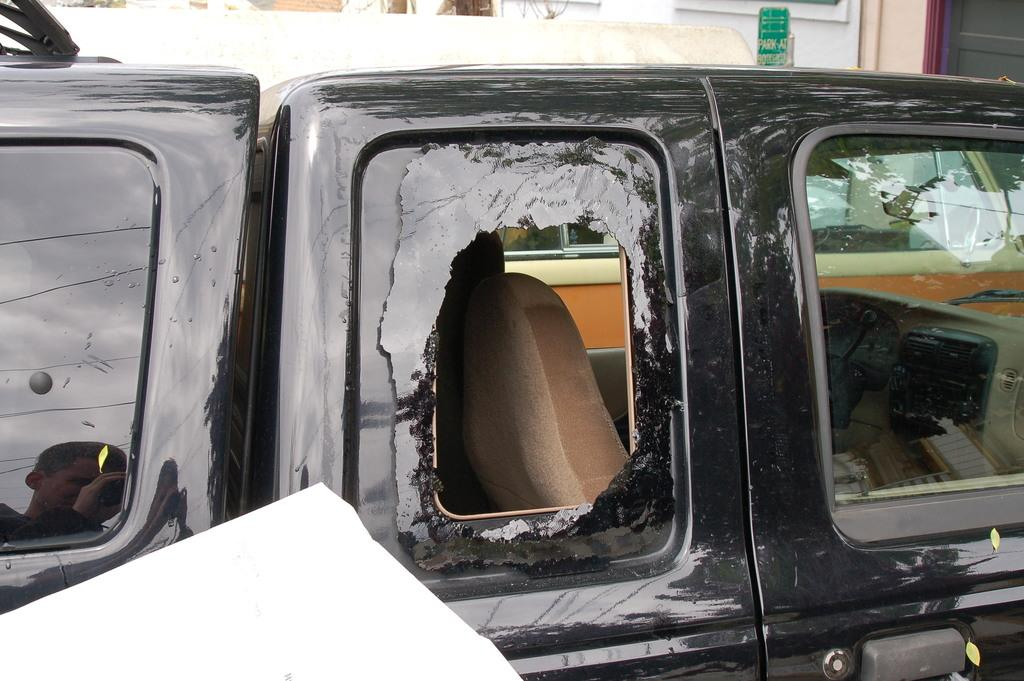What color is the car in the image? The car in the image is black. What type of windows does the car have? The car has glass windows. What can be seen beside the car in the image? There is a white color object beside the car. What is visible in the background of the image? There is a building in the background of the image. Is there a guide wearing a crown and riding a carriage in the image? No, there is no guide, crown, or carriage present in the image. 